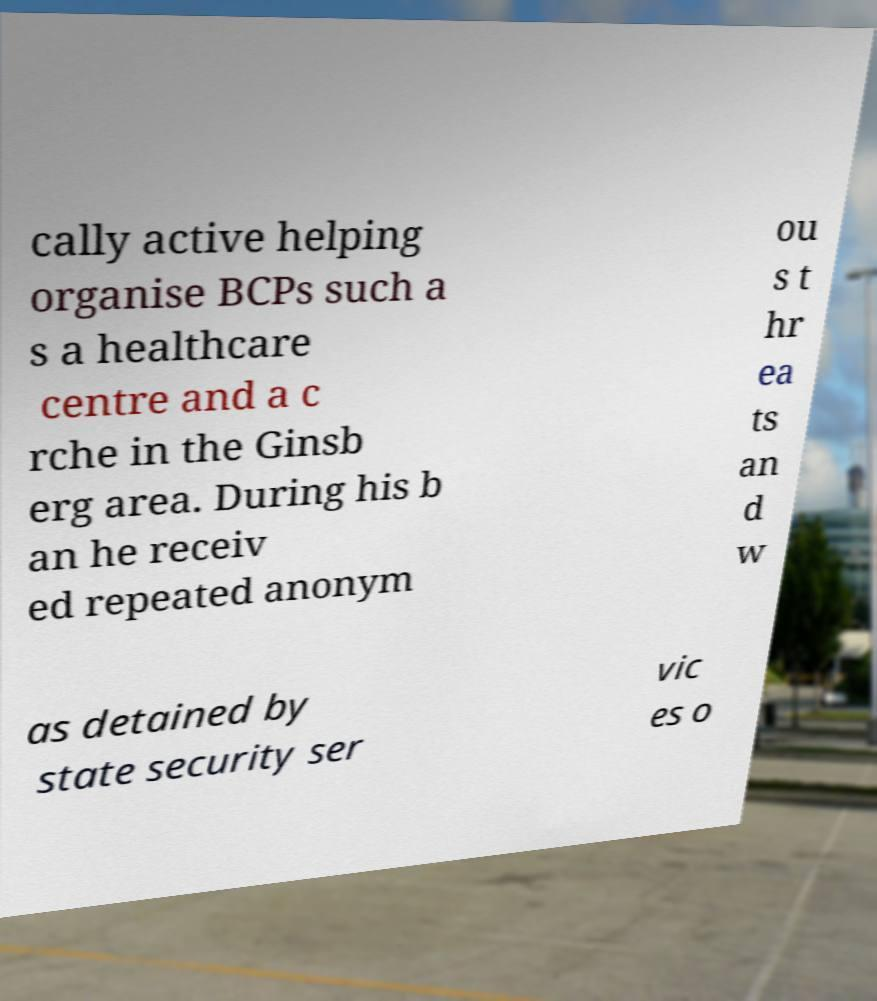I need the written content from this picture converted into text. Can you do that? cally active helping organise BCPs such a s a healthcare centre and a c rche in the Ginsb erg area. During his b an he receiv ed repeated anonym ou s t hr ea ts an d w as detained by state security ser vic es o 